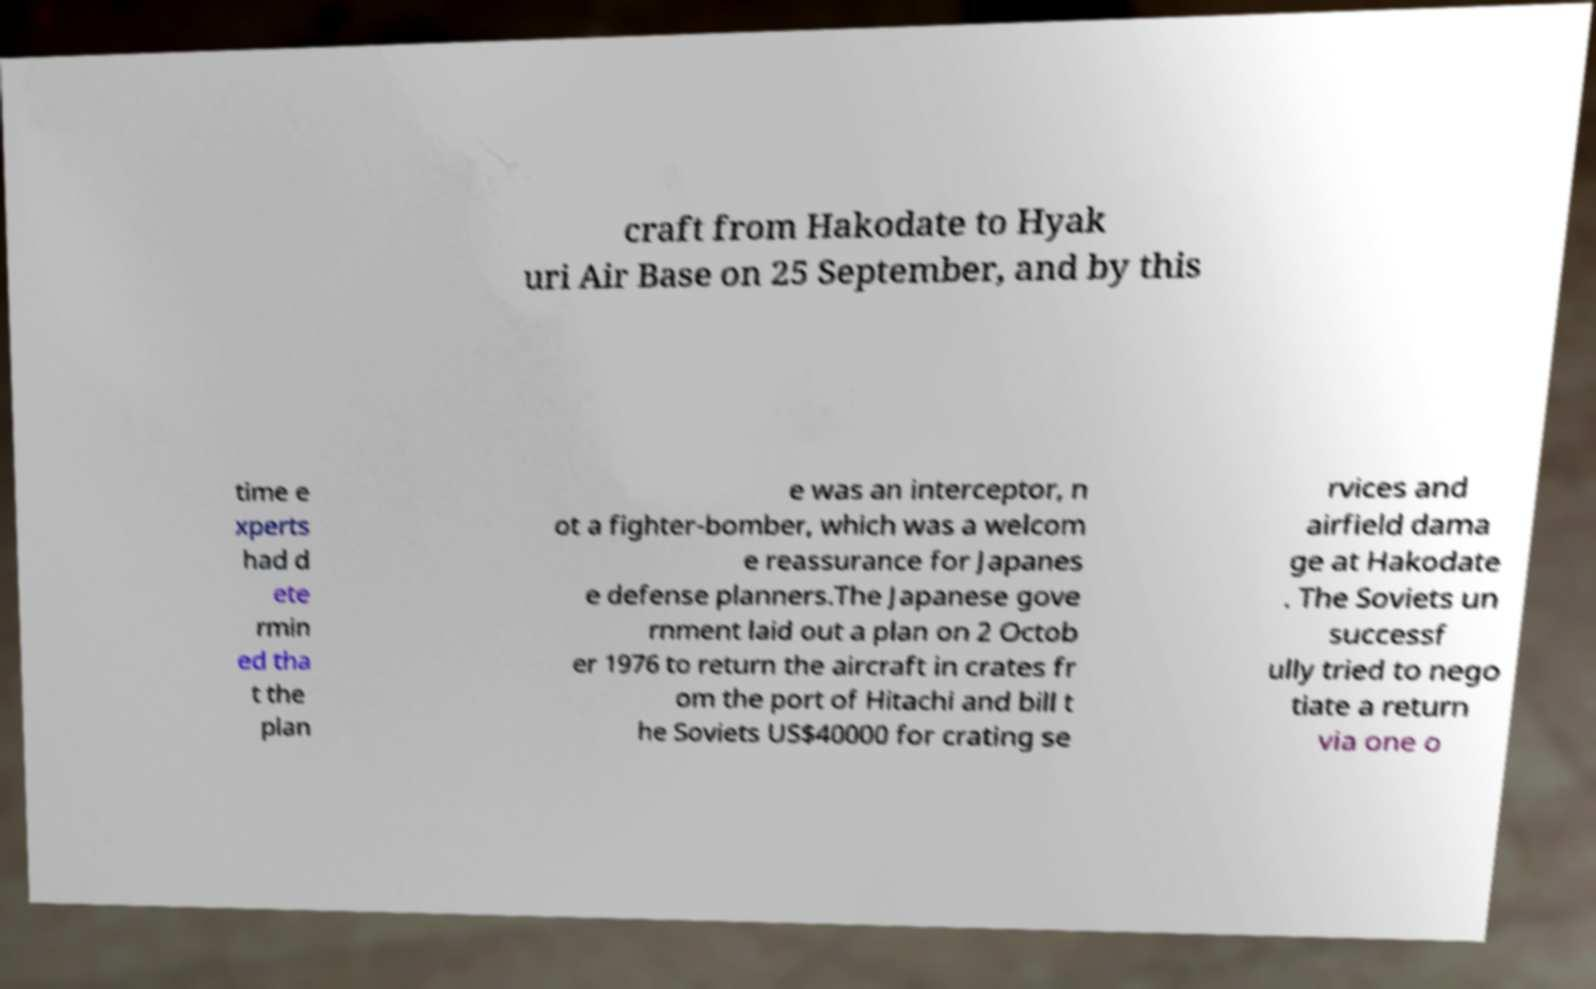Please identify and transcribe the text found in this image. craft from Hakodate to Hyak uri Air Base on 25 September, and by this time e xperts had d ete rmin ed tha t the plan e was an interceptor, n ot a fighter-bomber, which was a welcom e reassurance for Japanes e defense planners.The Japanese gove rnment laid out a plan on 2 Octob er 1976 to return the aircraft in crates fr om the port of Hitachi and bill t he Soviets US$40000 for crating se rvices and airfield dama ge at Hakodate . The Soviets un successf ully tried to nego tiate a return via one o 